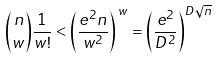Convert formula to latex. <formula><loc_0><loc_0><loc_500><loc_500>\binom { n } { w } \frac { 1 } { w ! } < \left ( \frac { e ^ { 2 } n } { w ^ { 2 } } \right ) ^ { \, w } = \left ( \frac { e ^ { 2 } } { D ^ { 2 } } \right ) ^ { D \sqrt { n } }</formula> 